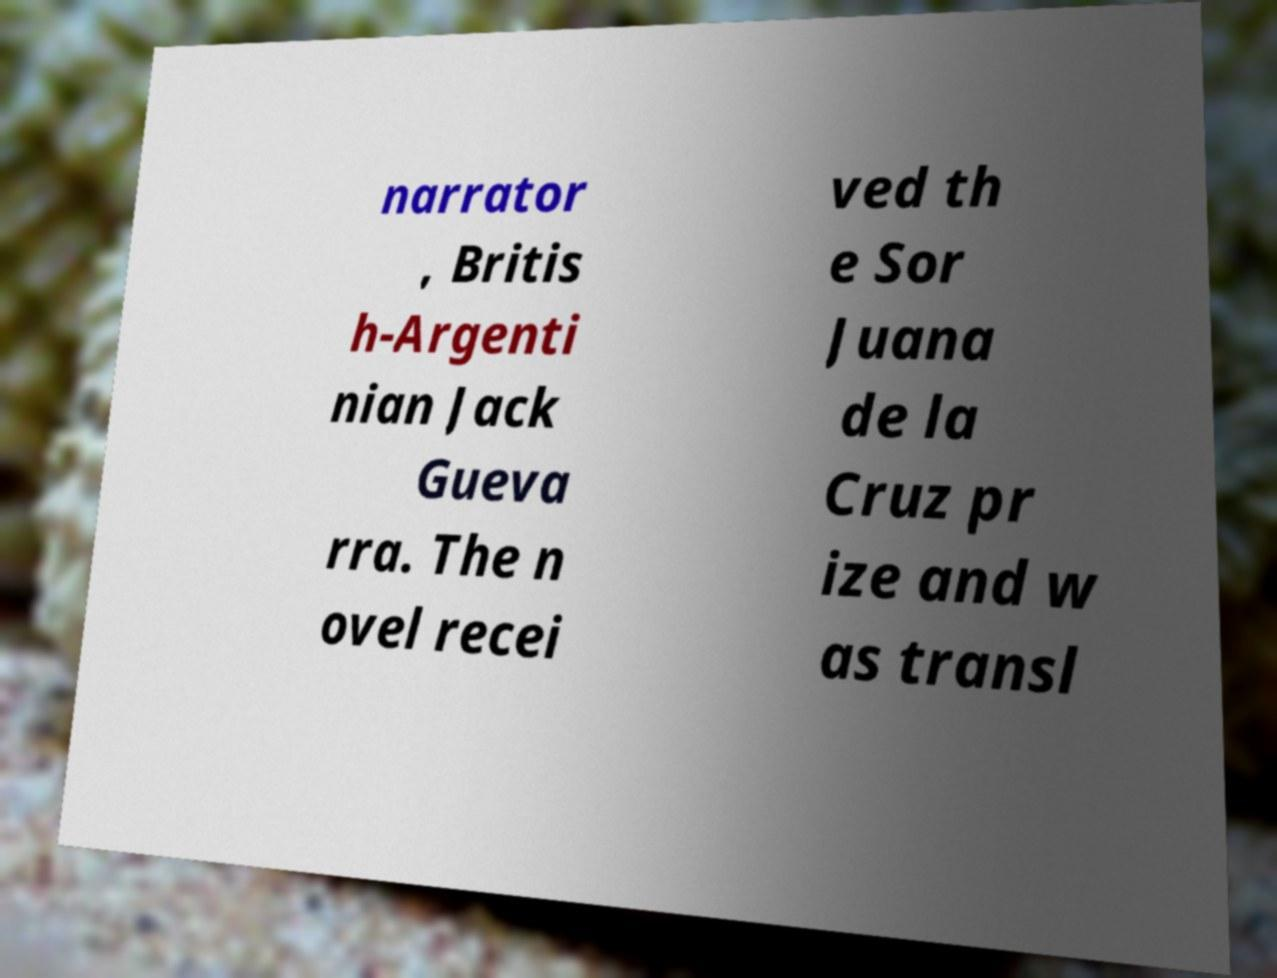Please identify and transcribe the text found in this image. narrator , Britis h-Argenti nian Jack Gueva rra. The n ovel recei ved th e Sor Juana de la Cruz pr ize and w as transl 